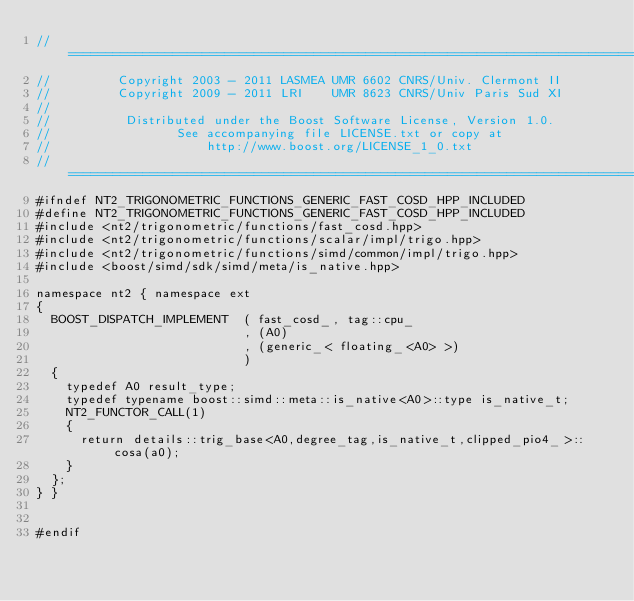<code> <loc_0><loc_0><loc_500><loc_500><_C++_>//==============================================================================
//         Copyright 2003 - 2011 LASMEA UMR 6602 CNRS/Univ. Clermont II
//         Copyright 2009 - 2011 LRI    UMR 8623 CNRS/Univ Paris Sud XI
//
//          Distributed under the Boost Software License, Version 1.0.
//                 See accompanying file LICENSE.txt or copy at
//                     http://www.boost.org/LICENSE_1_0.txt
//==============================================================================
#ifndef NT2_TRIGONOMETRIC_FUNCTIONS_GENERIC_FAST_COSD_HPP_INCLUDED
#define NT2_TRIGONOMETRIC_FUNCTIONS_GENERIC_FAST_COSD_HPP_INCLUDED
#include <nt2/trigonometric/functions/fast_cosd.hpp>
#include <nt2/trigonometric/functions/scalar/impl/trigo.hpp>
#include <nt2/trigonometric/functions/simd/common/impl/trigo.hpp>
#include <boost/simd/sdk/simd/meta/is_native.hpp>

namespace nt2 { namespace ext
{
  BOOST_DISPATCH_IMPLEMENT  ( fast_cosd_, tag::cpu_
                            , (A0)
                            , (generic_< floating_<A0> >)
                            )
  {
    typedef A0 result_type;
    typedef typename boost::simd::meta::is_native<A0>::type is_native_t;
    NT2_FUNCTOR_CALL(1)
    {
      return details::trig_base<A0,degree_tag,is_native_t,clipped_pio4_>::cosa(a0);
    }
  };
} }


#endif
</code> 